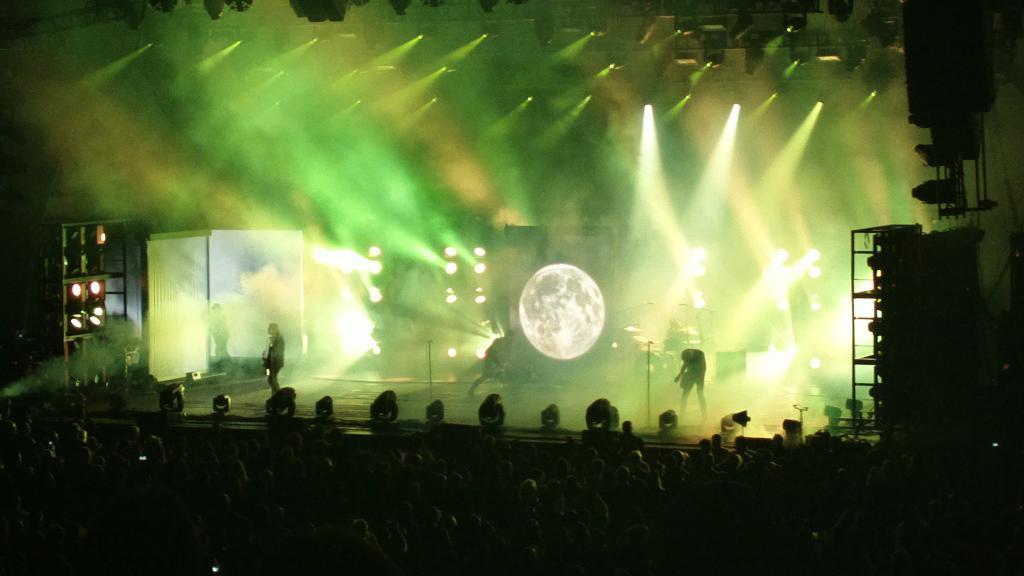How would you summarize this image in a sentence or two? At the bottom of the image few people are standing. In the middle of the image few people are standing and holding some musical instruments and there are some microphones. Behind them there are some lights. At the top of the image we can see some lights. 